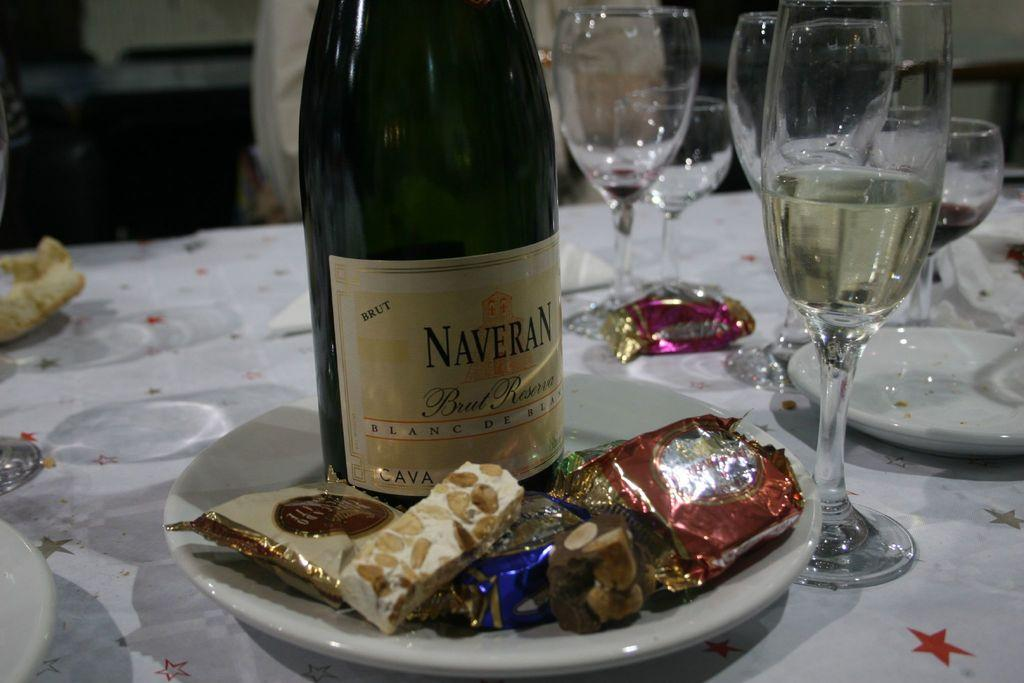What type of beverage container is present in the image? There is a wine bottle in the image. What edible items can be seen in the image? There are chocolates and cookies in the image. What is the color of the plate containing the chocolates and cookies? The plate containing the chocolates and cookies is white. What type of tableware is present in the image? There are glasses and plates in the image. What other objects can be seen on the table? There are other objects on the table, but their specific details are not mentioned in the provided facts. What type of scene is depicted in the image? The provided facts do not mention any specific scene or setting, so it cannot be determined from the image. Can you see any tramps in the image? There is no mention of a tramp or any person in the image, so it cannot be determined from the image. 